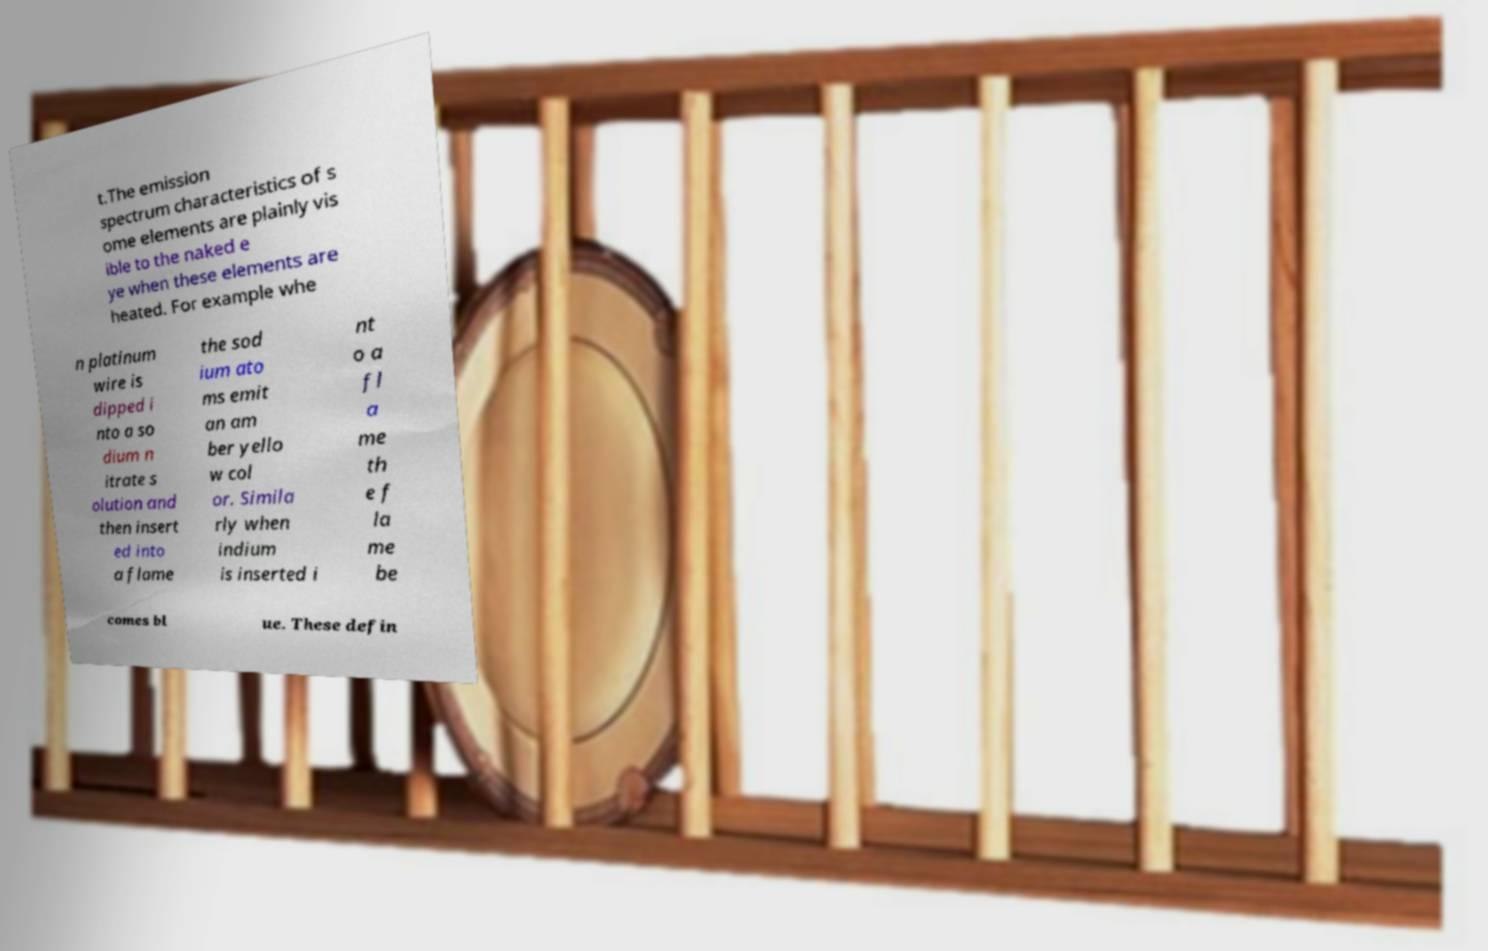Can you accurately transcribe the text from the provided image for me? t.The emission spectrum characteristics of s ome elements are plainly vis ible to the naked e ye when these elements are heated. For example whe n platinum wire is dipped i nto a so dium n itrate s olution and then insert ed into a flame the sod ium ato ms emit an am ber yello w col or. Simila rly when indium is inserted i nt o a fl a me th e f la me be comes bl ue. These defin 